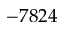<formula> <loc_0><loc_0><loc_500><loc_500>- 7 8 2 4</formula> 